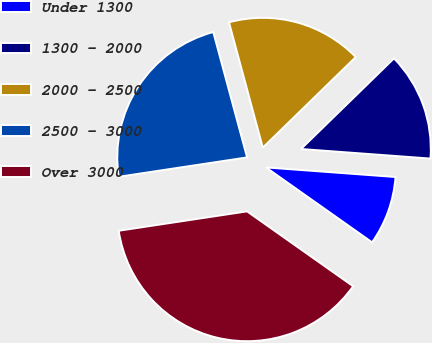Convert chart to OTSL. <chart><loc_0><loc_0><loc_500><loc_500><pie_chart><fcel>Under 1300<fcel>1300 - 2000<fcel>2000 - 2500<fcel>2500 - 3000<fcel>Over 3000<nl><fcel>8.61%<fcel>13.47%<fcel>16.9%<fcel>23.19%<fcel>37.83%<nl></chart> 